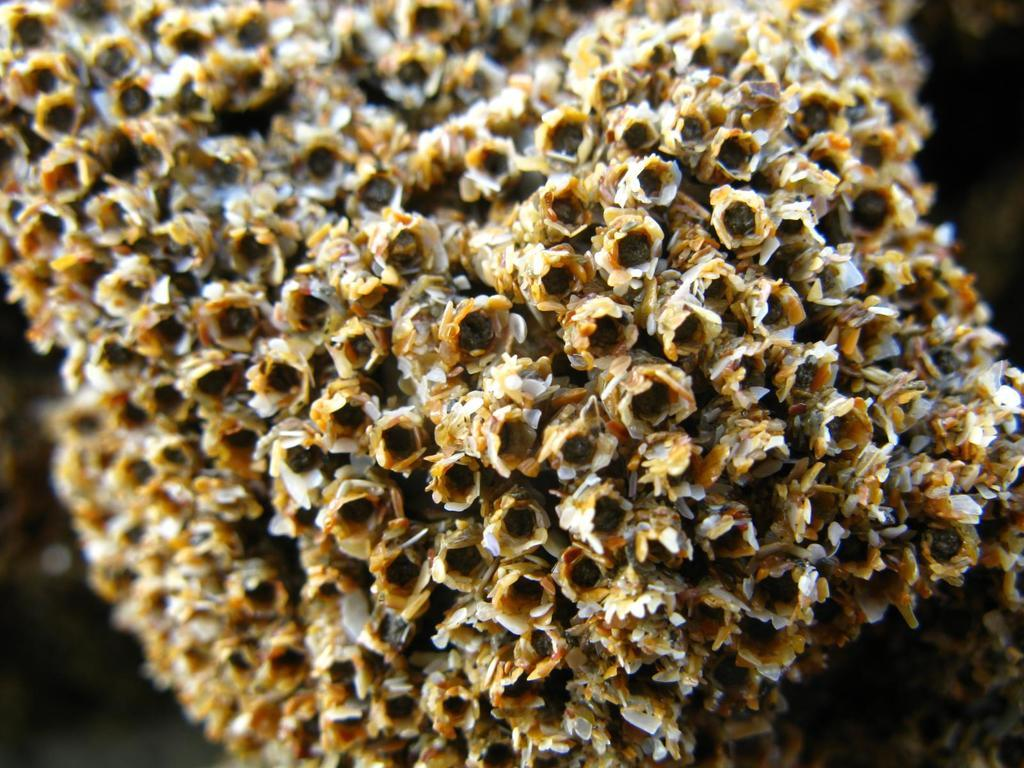What is the main subject of the image? The main subject of the image is a honeycomb. How many beds are visible in the image? There are no beds present in the image; it features a honeycomb. What type of crate is used to store the wine in the image? There is no crate or wine present in the image; it features a honeycomb. 